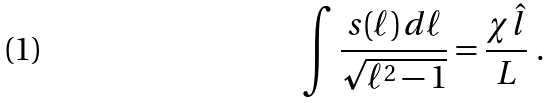Convert formula to latex. <formula><loc_0><loc_0><loc_500><loc_500>\int \frac { s ( \ell ) \, d \ell } { \sqrt { \ell ^ { 2 } - 1 } } = \frac { \chi \hat { l } } { L } \ .</formula> 